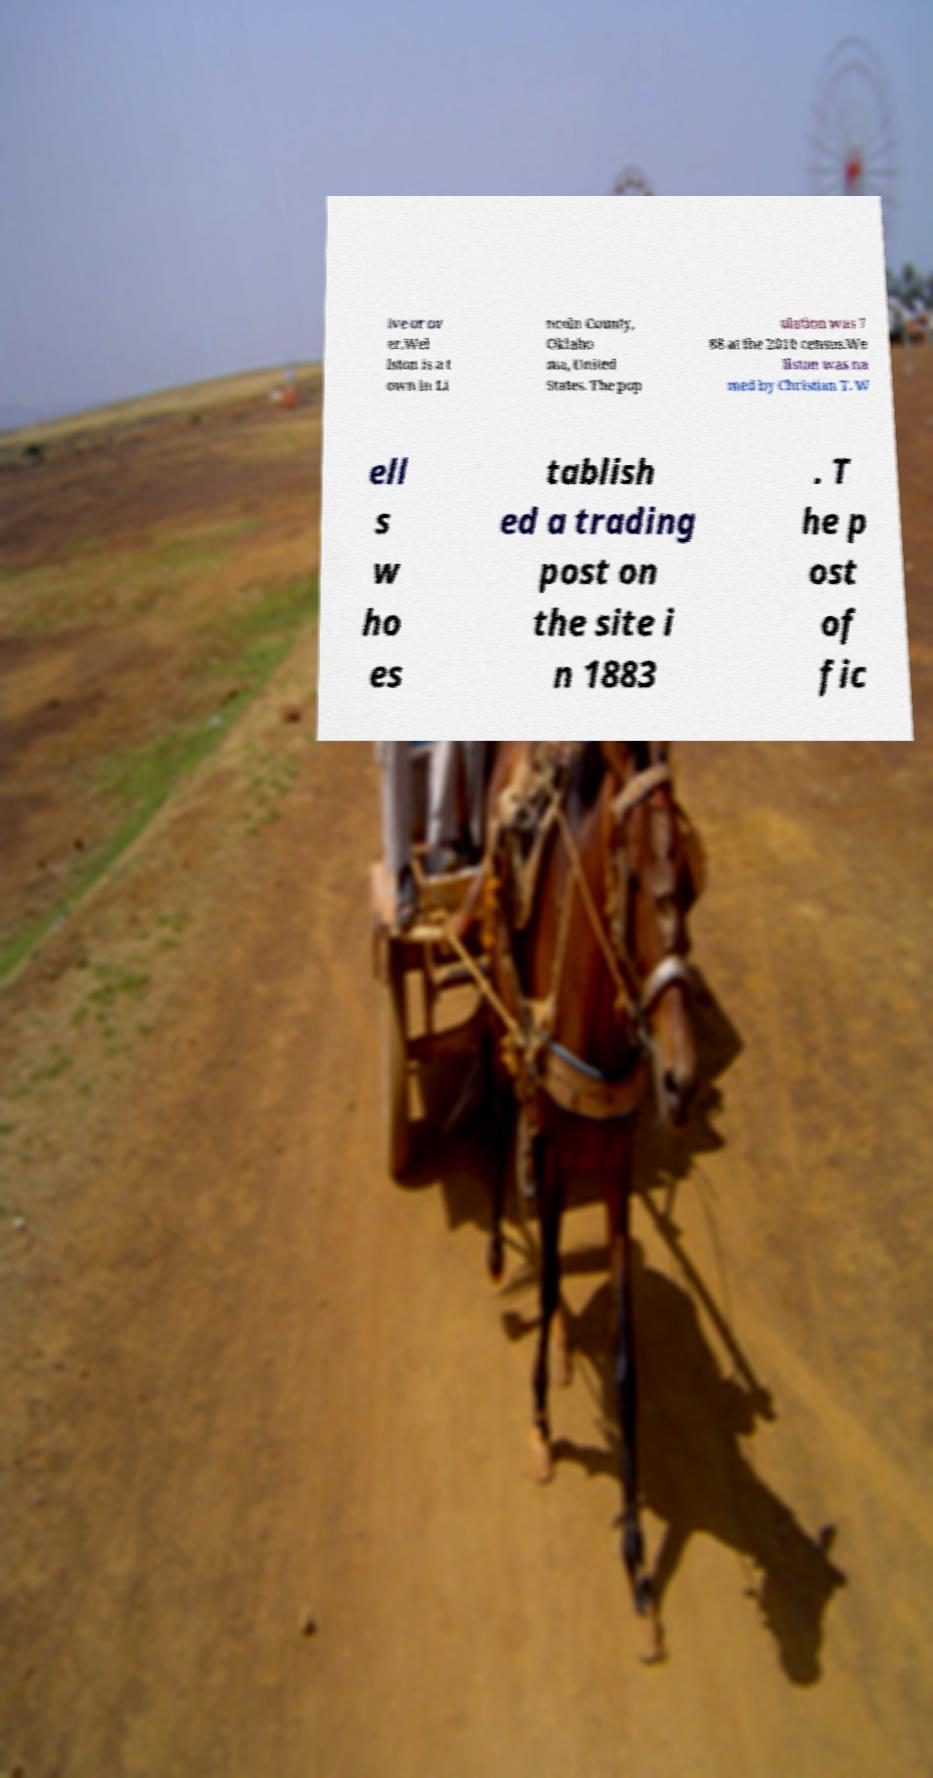What messages or text are displayed in this image? I need them in a readable, typed format. ive or ov er.Wel lston is a t own in Li ncoln County, Oklaho ma, United States. The pop ulation was 7 88 at the 2010 census.We llston was na med by Christian T. W ell s w ho es tablish ed a trading post on the site i n 1883 . T he p ost of fic 